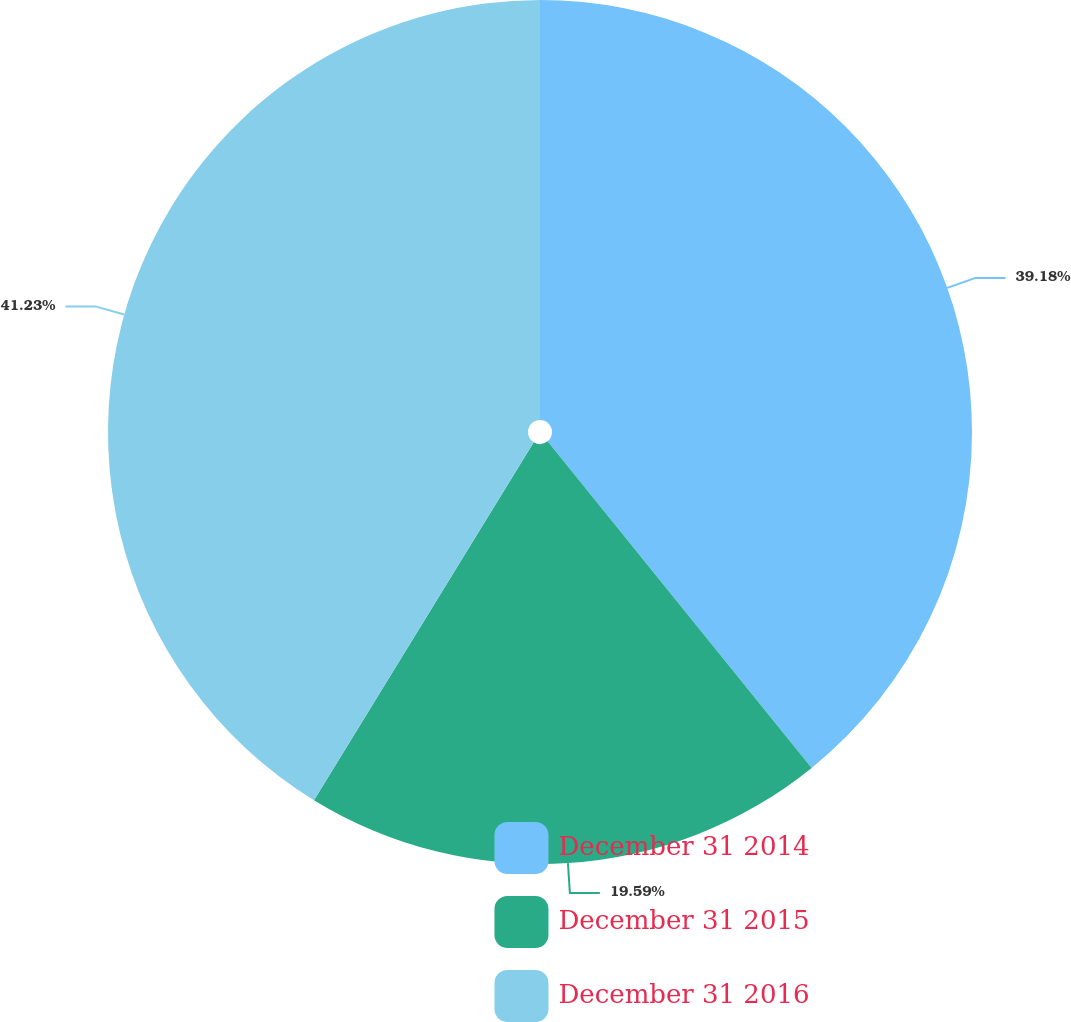<chart> <loc_0><loc_0><loc_500><loc_500><pie_chart><fcel>December 31 2014<fcel>December 31 2015<fcel>December 31 2016<nl><fcel>39.18%<fcel>19.59%<fcel>41.24%<nl></chart> 